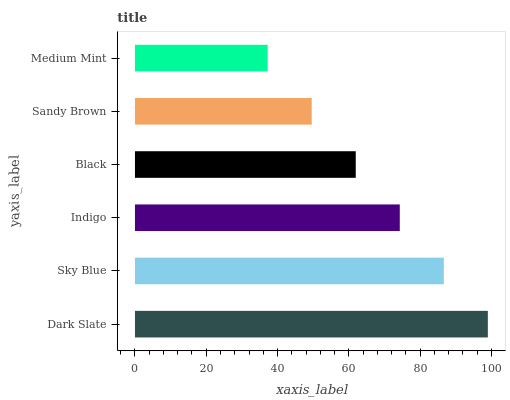Is Medium Mint the minimum?
Answer yes or no. Yes. Is Dark Slate the maximum?
Answer yes or no. Yes. Is Sky Blue the minimum?
Answer yes or no. No. Is Sky Blue the maximum?
Answer yes or no. No. Is Dark Slate greater than Sky Blue?
Answer yes or no. Yes. Is Sky Blue less than Dark Slate?
Answer yes or no. Yes. Is Sky Blue greater than Dark Slate?
Answer yes or no. No. Is Dark Slate less than Sky Blue?
Answer yes or no. No. Is Indigo the high median?
Answer yes or no. Yes. Is Black the low median?
Answer yes or no. Yes. Is Medium Mint the high median?
Answer yes or no. No. Is Dark Slate the low median?
Answer yes or no. No. 